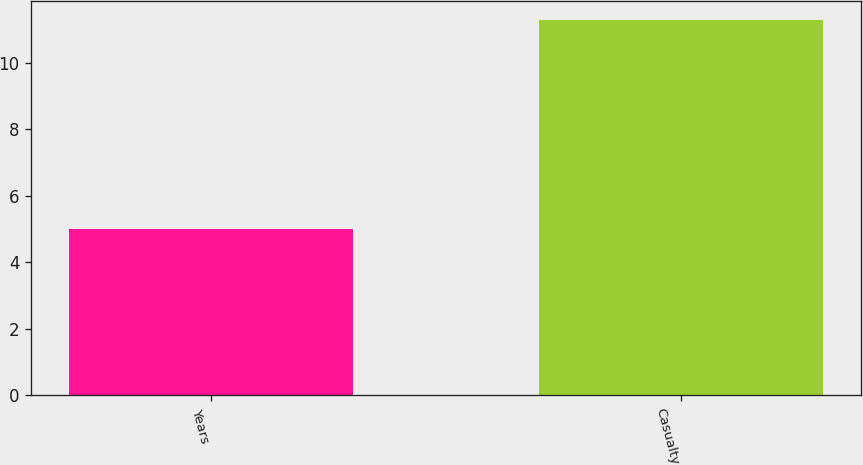Convert chart. <chart><loc_0><loc_0><loc_500><loc_500><bar_chart><fcel>Years<fcel>Casualty<nl><fcel>5<fcel>11.3<nl></chart> 